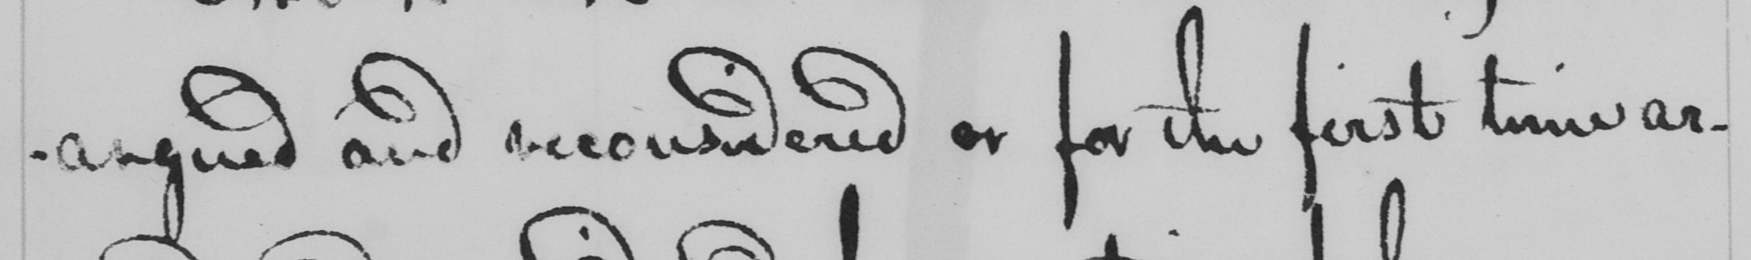What text is written in this handwritten line? -argued and reconsidered or for the first time ar- 